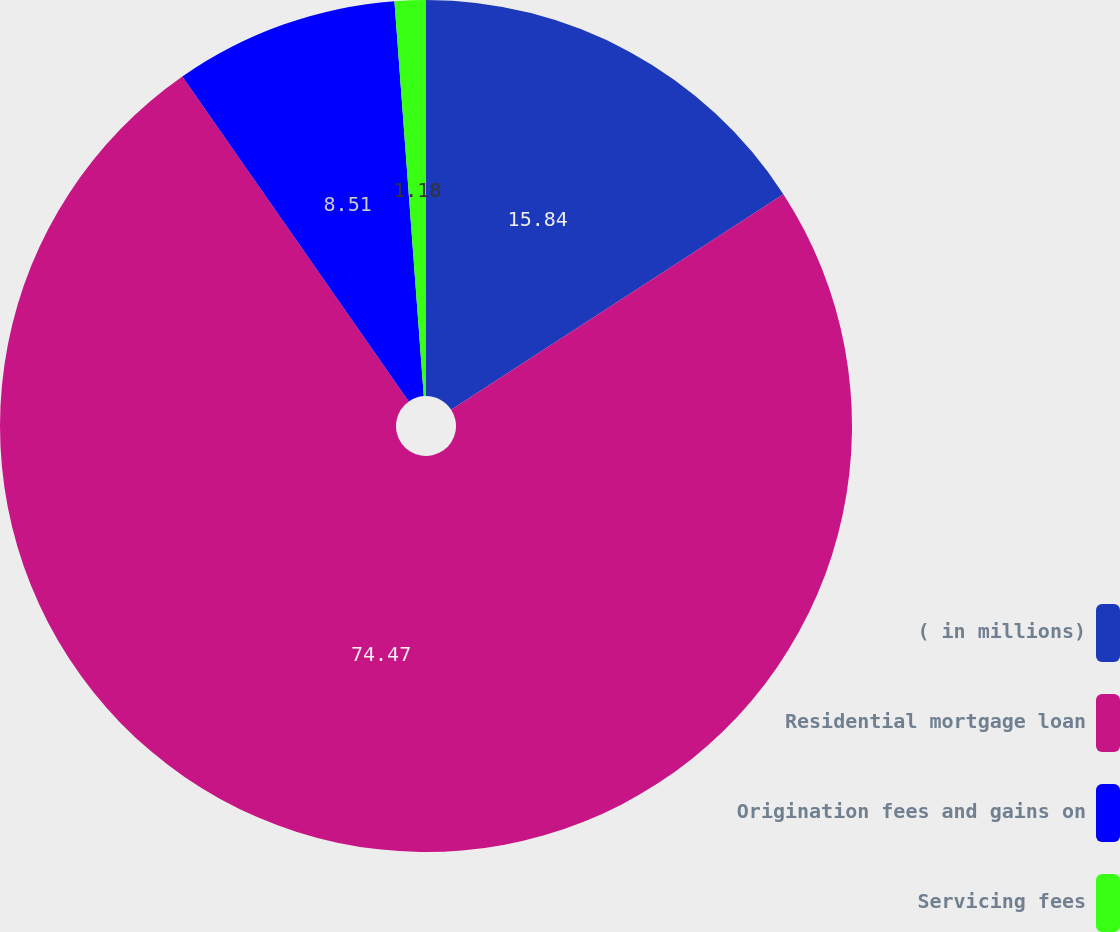Convert chart. <chart><loc_0><loc_0><loc_500><loc_500><pie_chart><fcel>( in millions)<fcel>Residential mortgage loan<fcel>Origination fees and gains on<fcel>Servicing fees<nl><fcel>15.84%<fcel>74.47%<fcel>8.51%<fcel>1.18%<nl></chart> 